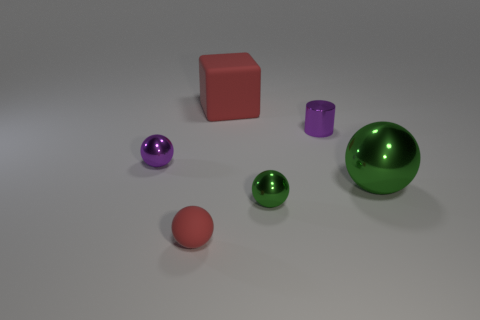Subtract all green balls. How many were subtracted if there are1green balls left? 1 Subtract all big green balls. How many balls are left? 3 Subtract all red balls. How many balls are left? 3 Add 1 tiny red things. How many objects exist? 7 Subtract all cyan blocks. How many green balls are left? 2 Subtract all cubes. How many objects are left? 5 Subtract 2 balls. How many balls are left? 2 Subtract all purple metal objects. Subtract all cylinders. How many objects are left? 3 Add 2 cubes. How many cubes are left? 3 Add 2 tiny metallic spheres. How many tiny metallic spheres exist? 4 